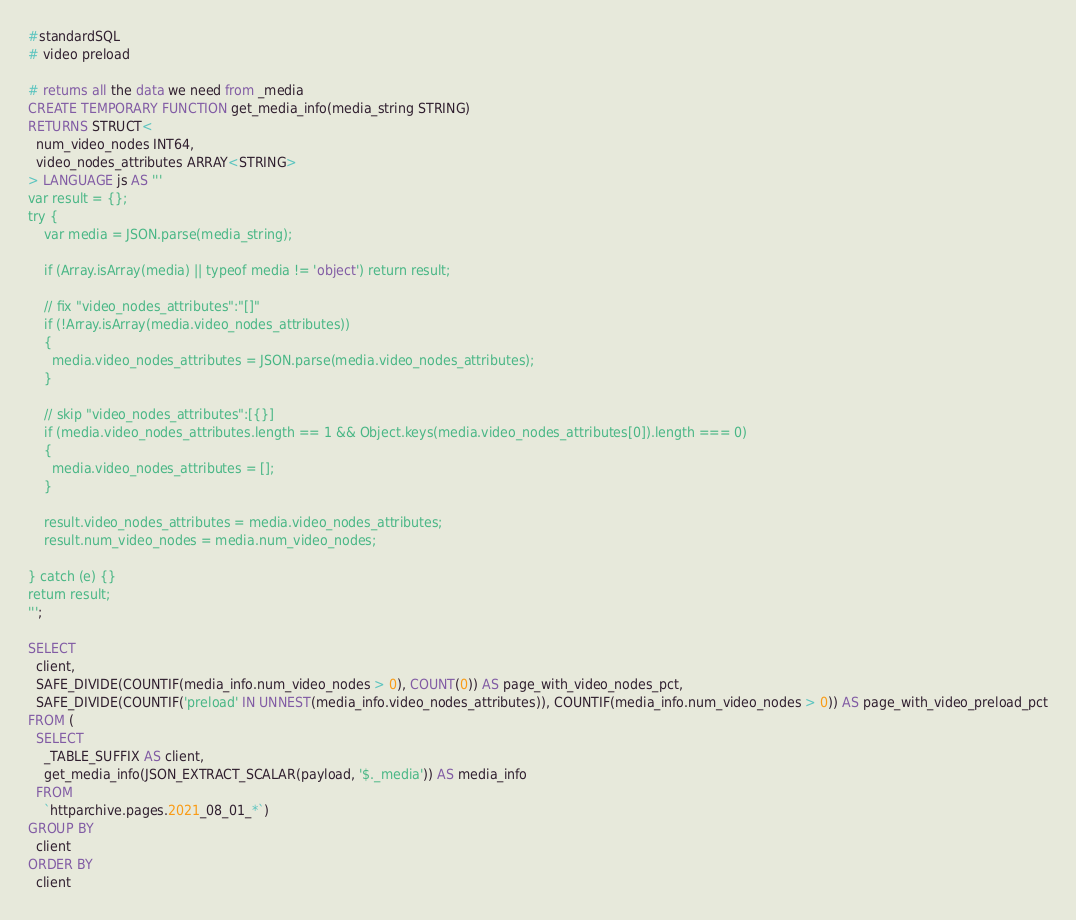<code> <loc_0><loc_0><loc_500><loc_500><_SQL_>#standardSQL
# video preload

# returns all the data we need from _media
CREATE TEMPORARY FUNCTION get_media_info(media_string STRING)
RETURNS STRUCT<
  num_video_nodes INT64,
  video_nodes_attributes ARRAY<STRING>
> LANGUAGE js AS '''
var result = {};
try {
    var media = JSON.parse(media_string);

    if (Array.isArray(media) || typeof media != 'object') return result;

    // fix "video_nodes_attributes":"[]"
    if (!Array.isArray(media.video_nodes_attributes))
    {
      media.video_nodes_attributes = JSON.parse(media.video_nodes_attributes);
    }

    // skip "video_nodes_attributes":[{}]
    if (media.video_nodes_attributes.length == 1 && Object.keys(media.video_nodes_attributes[0]).length === 0)
    {
      media.video_nodes_attributes = [];
    }

    result.video_nodes_attributes = media.video_nodes_attributes;
    result.num_video_nodes = media.num_video_nodes;

} catch (e) {}
return result;
''';

SELECT
  client,
  SAFE_DIVIDE(COUNTIF(media_info.num_video_nodes > 0), COUNT(0)) AS page_with_video_nodes_pct,
  SAFE_DIVIDE(COUNTIF('preload' IN UNNEST(media_info.video_nodes_attributes)), COUNTIF(media_info.num_video_nodes > 0)) AS page_with_video_preload_pct
FROM (
  SELECT
    _TABLE_SUFFIX AS client,
    get_media_info(JSON_EXTRACT_SCALAR(payload, '$._media')) AS media_info
  FROM
    `httparchive.pages.2021_08_01_*`)
GROUP BY
  client
ORDER BY
  client
</code> 